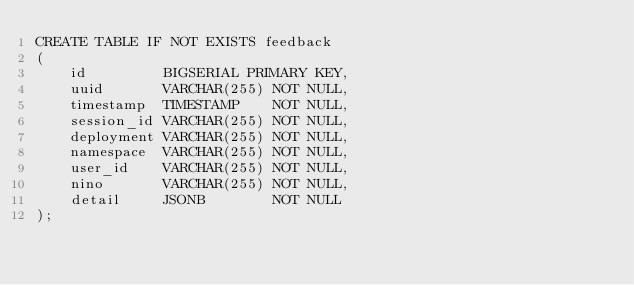Convert code to text. <code><loc_0><loc_0><loc_500><loc_500><_SQL_>CREATE TABLE IF NOT EXISTS feedback
(
    id         BIGSERIAL PRIMARY KEY,
    uuid       VARCHAR(255) NOT NULL,
    timestamp  TIMESTAMP    NOT NULL,
    session_id VARCHAR(255) NOT NULL,
    deployment VARCHAR(255) NOT NULL,
    namespace  VARCHAR(255) NOT NULL,
    user_id    VARCHAR(255) NOT NULL,
    nino       VARCHAR(255) NOT NULL,
    detail     JSONB        NOT NULL
);
</code> 